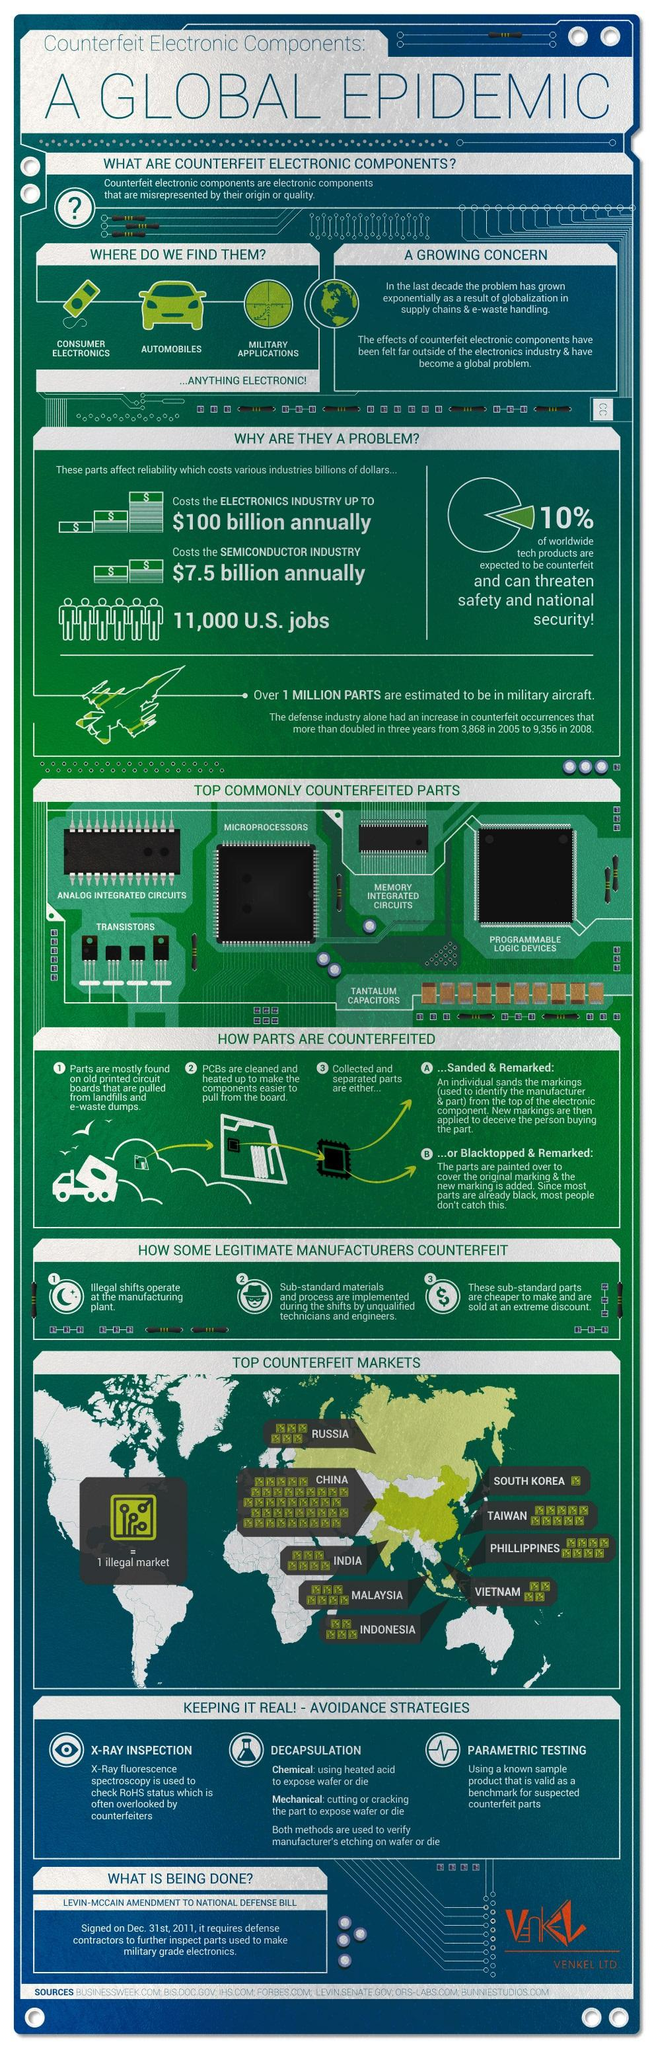Mention a couple of crucial points in this snapshot. The presence of counterfeit electronic components in an industry has a significant impact on its financial stability, with the semiconductor industry being affected the second most monetarily. The electronics industry is the most financially impacted by counterfeit electronic components. China is known to have the most counterfeit markets. The number of counterfeit occurrences in the defense industry increased from 2005 to 2008, with a total increase of 5,488. South Korea has the least number of counterfeit markets out of the countries listed in the infographic. 